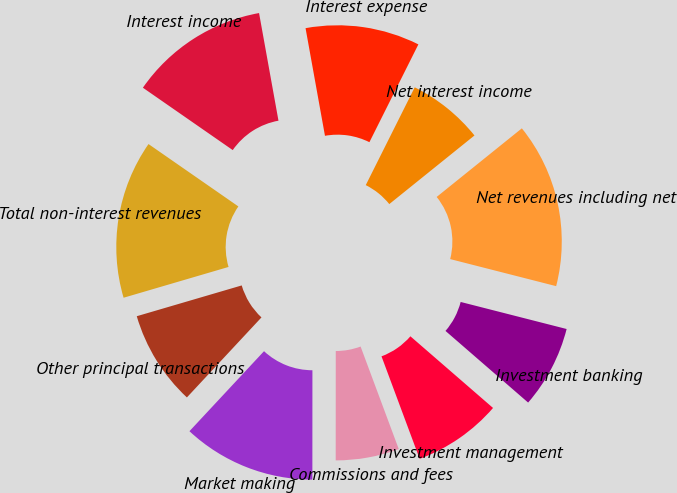Convert chart to OTSL. <chart><loc_0><loc_0><loc_500><loc_500><pie_chart><fcel>Investment banking<fcel>Investment management<fcel>Commissions and fees<fcel>Market making<fcel>Other principal transactions<fcel>Total non-interest revenues<fcel>Interest income<fcel>Interest expense<fcel>Net interest income<fcel>Net revenues including net<nl><fcel>7.39%<fcel>7.96%<fcel>5.68%<fcel>11.93%<fcel>8.52%<fcel>14.2%<fcel>12.5%<fcel>10.23%<fcel>6.82%<fcel>14.77%<nl></chart> 